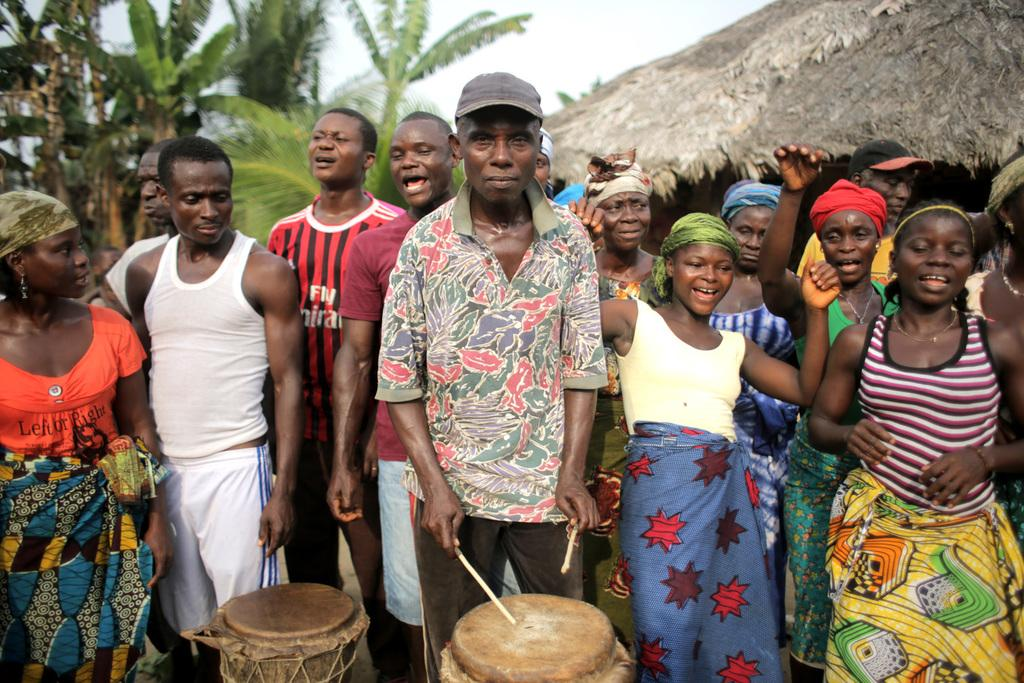How many people can be seen in the image? There are many people standing in the image. What is the main activity taking place in the image? A man is playing the drums in the center of the image. What can be seen in the background of the image? There is a hurdle and trees in the background of the image. What is visible above the trees and hurdle in the image? The sky is visible in the background of the image. Where is the store located in the image? There is no store present in the image. What type of spark can be seen coming from the drummer's drumsticks? There is no spark visible in the image; the drummer is simply playing the drums. 